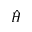Convert formula to latex. <formula><loc_0><loc_0><loc_500><loc_500>\hat { H }</formula> 